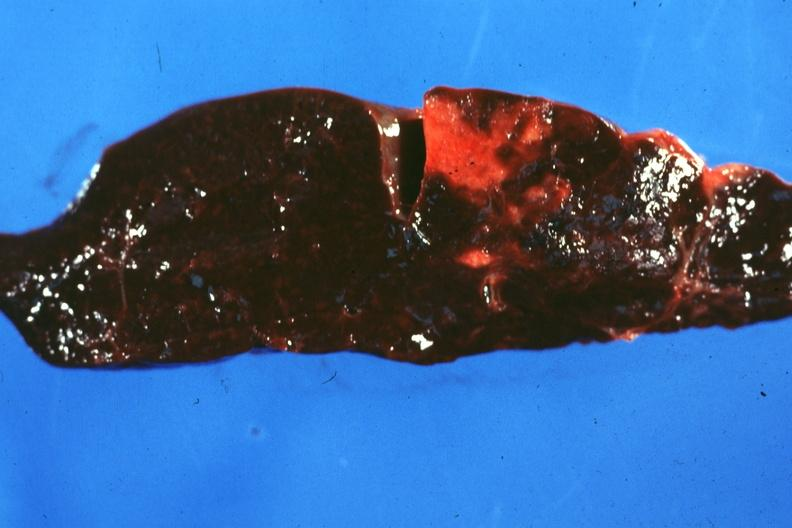s metastatic neuroblastoma present?
Answer the question using a single word or phrase. No 